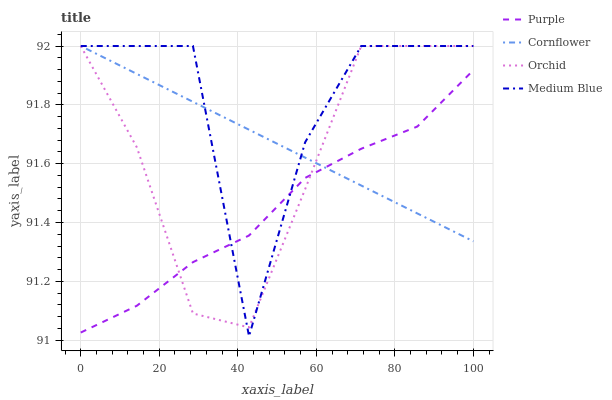Does Purple have the minimum area under the curve?
Answer yes or no. Yes. Does Medium Blue have the maximum area under the curve?
Answer yes or no. Yes. Does Cornflower have the minimum area under the curve?
Answer yes or no. No. Does Cornflower have the maximum area under the curve?
Answer yes or no. No. Is Cornflower the smoothest?
Answer yes or no. Yes. Is Medium Blue the roughest?
Answer yes or no. Yes. Is Medium Blue the smoothest?
Answer yes or no. No. Is Cornflower the roughest?
Answer yes or no. No. Does Medium Blue have the lowest value?
Answer yes or no. Yes. Does Cornflower have the lowest value?
Answer yes or no. No. Does Orchid have the highest value?
Answer yes or no. Yes. Does Orchid intersect Cornflower?
Answer yes or no. Yes. Is Orchid less than Cornflower?
Answer yes or no. No. Is Orchid greater than Cornflower?
Answer yes or no. No. 